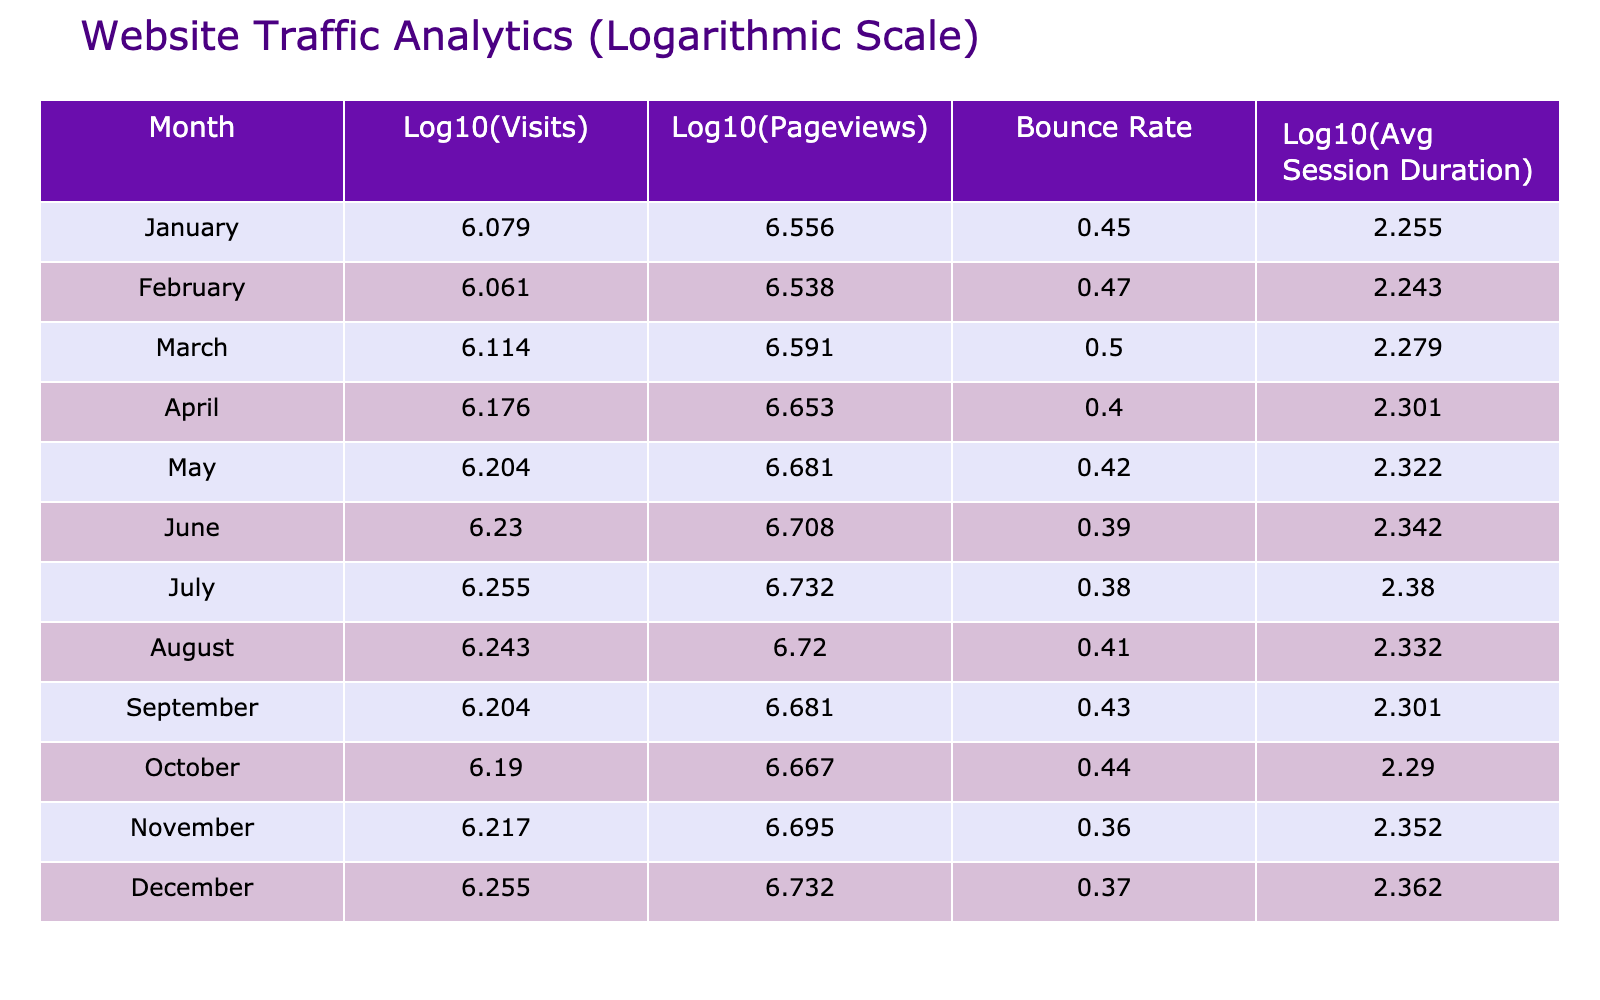What were the log10(Visits) for December? In the table, find the value for log10(Visits) in the row for December. It shows log10(Visits) = 6.255
Answer: 6.255 Which month had the highest Bounce Rate? By checking the Bounce Rate column for each month, I see that November has the highest Bounce Rate at 0.36
Answer: 0.36 What is the change in log10(Pageviews) from January to February? The value for log10(Pageviews) in January is 6.556, and in February it is 6.539. The change is 6.556 - 6.539 = 0.017
Answer: 0.017 Is the Average Session Duration higher in July than in June? In the table, July has an Average Session Duration of 240 seconds, while June has 220 seconds. Thus, July's duration is higher than June's.
Answer: Yes Calculate the average bounce rate for the second half of the year (July to December). The Bounce Rates for July to December are 0.38, 0.41, 0.43, 0.44, 0.36, and 0.37. To find the average, sum these values: 0.38 + 0.41 + 0.43 + 0.44 + 0.36 + 0.37 = 2.39. Then divide by the number of months (6): 2.39 / 6 = 0.3983.
Answer: 0.3983 In which month did the log10(Visits) first exceed 6.1? Checking the log10(Visits) values in order, January (6.079), February (6.060), March (6.113), and so on. The first month with log10(Visits) exceeding 6.1 is March.
Answer: March What is the difference in log10(Avg Session Duration) between May and November? The log10(Avg Session Duration) for May is 2.322 and for November it is 2.352. The difference is calculated by subtracting: 2.352 - 2.322 = 0.030.
Answer: 0.030 Was the log10(Pageviews) in October higher than in September? Looking at the values for log10(Pageviews), October is 6.668 and September is 6.607. Since 6.668 is greater than 6.607, October has a higher value.
Answer: Yes Identify the month with the lowest log10(Avg Session Duration)? Reviewing the log10(Avg Session Duration) values, the lowest is in June with a value of 2.342.
Answer: June 